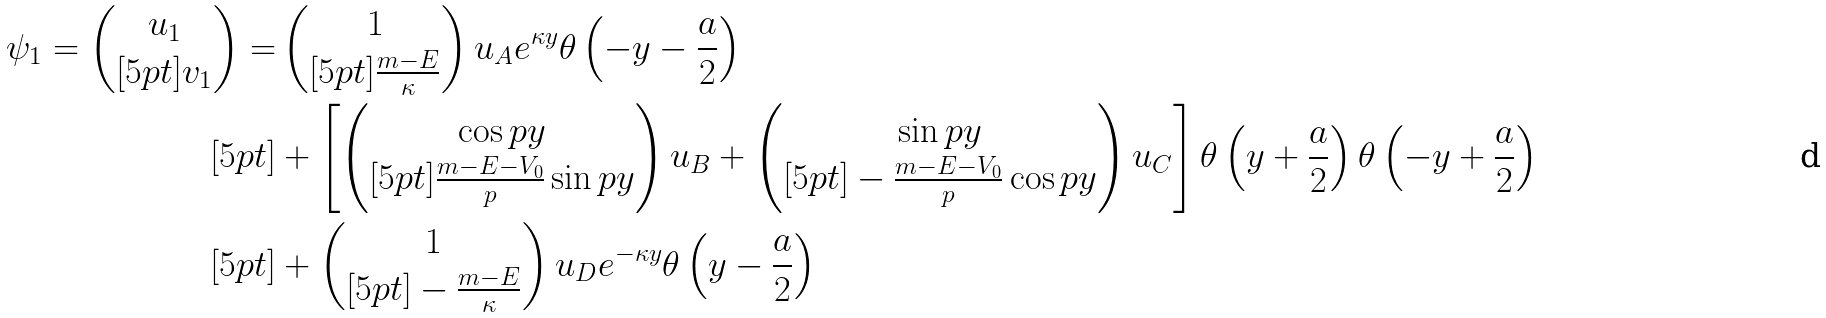<formula> <loc_0><loc_0><loc_500><loc_500>\psi _ { 1 } = \left ( \begin{matrix} u _ { 1 } \\ [ 5 p t ] v _ { 1 } \end{matrix} \right ) = & \left ( \begin{matrix} 1 \\ [ 5 p t ] \frac { m - E } { \kappa } \end{matrix} \right ) u _ { A } e ^ { \kappa y } \theta \left ( - y - \frac { a } { 2 } \right ) \\ [ 5 p t ] & + \left [ \left ( \begin{matrix} \cos p y \\ [ 5 p t ] \frac { m - E - V _ { 0 } } { p } \sin p y \end{matrix} \right ) u _ { B } + \left ( \begin{matrix} \sin p y \\ [ 5 p t ] - \frac { m - E - V _ { 0 } } { p } \cos p y \end{matrix} \right ) u _ { C } \right ] \theta \left ( y + \frac { a } { 2 } \right ) \theta \left ( - y + \frac { a } { 2 } \right ) \\ [ 5 p t ] & + \left ( \begin{matrix} 1 \\ [ 5 p t ] - \frac { m - E } { \kappa } \end{matrix} \right ) u _ { D } e ^ { - \kappa y } \theta \left ( y - \frac { a } { 2 } \right )</formula> 